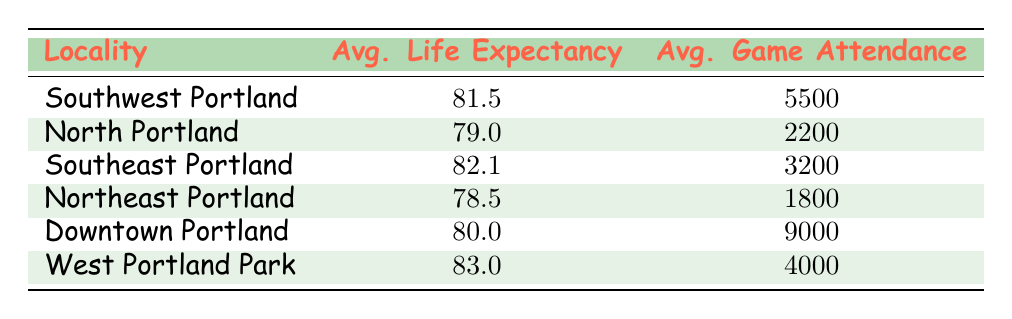What is the average life expectancy in Downtown Portland? The row for Downtown Portland shows an average life expectancy of 80.0.
Answer: 80.0 Which locality has the highest average life expectancy? The highest average life expectancy is found in West Portland Park with an average of 83.0.
Answer: West Portland Park What is the average game attendance in Southwest Portland? According to the table, Southwest Portland has an average game attendance of 5500.
Answer: 5500 Is the average life expectancy in Northeast Portland higher than in North Portland? Northeast Portland has an average life expectancy of 78.5, whereas North Portland has 79.0, so it is not higher.
Answer: No What is the difference in game attendance between Downtown Portland and Northeast Portland? Downtown Portland has an average game attendance of 9000, and Northeast Portland has 1800. The difference is 9000 - 1800 = 7200.
Answer: 7200 Calculate the average life expectancy of the localities with game attendance above 4000. The relevant localities are Southwest Portland (81.5), Downtown Portland (80.0), and West Portland Park (83.0). Adding these together gives 81.5 + 80.0 + 83.0 = 244.5, and dividing by 3 results in an average of 81.5.
Answer: 81.5 Is it true that Southeast Portland has a higher average game attendance than North Portland? Southeast Portland has an average game attendance of 3200, while North Portland has 2200, which confirms the statement is true.
Answer: Yes What is the average life expectancy among all localities listed? The average life expectancy can be calculated by summing all life expectancies: 81.5 + 79.0 + 82.1 + 78.5 + 80.0 + 83.0 = 484.1, and then dividing by the number of localities (6), giving an average of approximately 80.68.
Answer: 80.68 Which locality has the lowest average life expectancy? Northeast Portland has the lowest average life expectancy at 78.5.
Answer: Northeast Portland 